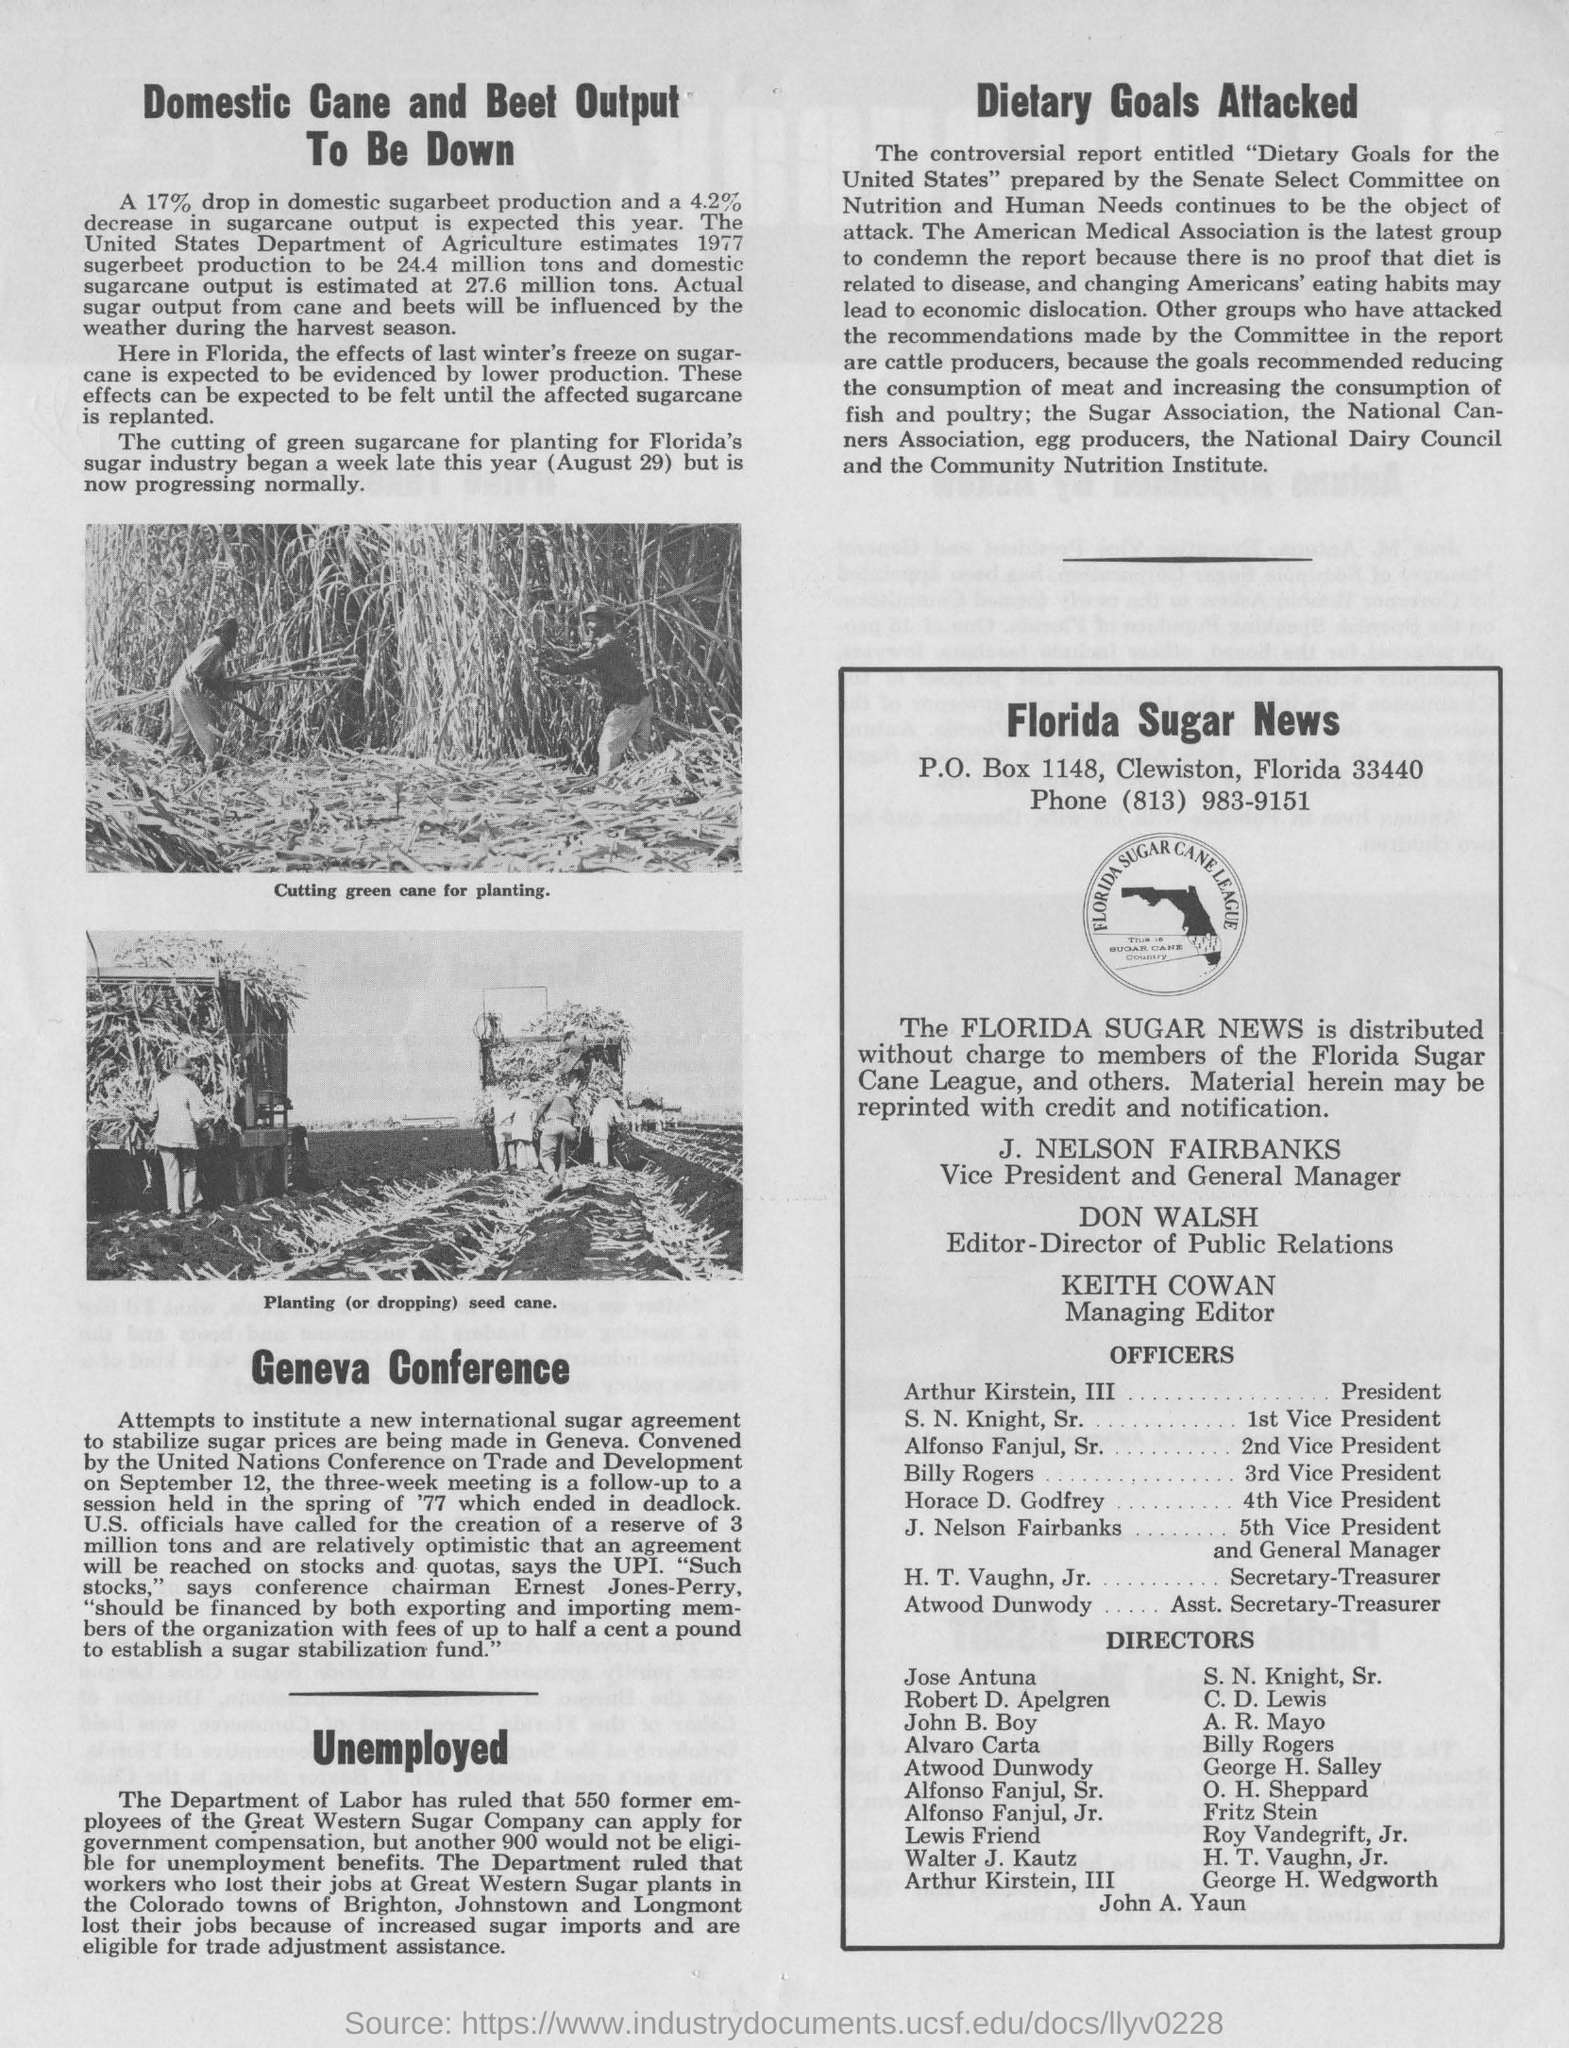Who is the Vice President and General Manager of The Florida Sugar News?
Make the answer very short. J. NELSON FAIRBANKS. What is the designation of Keith Cowan?
Your answer should be very brief. Managing Editor. How much percentage drop in domestic sugarbeet production is expected this year?
Offer a very short reply. 17%. How much percentage decrease in sugarcane output is expected this year?
Make the answer very short. 4.2%. Who prepared the controversial report entitled "Dietary Goals for the United States" ?
Ensure brevity in your answer.  Senate Select Committee on Nutrition and Human Needs. When did the cutting of green sugarcane for planting of Florida's sugar industry began?
Your response must be concise. A week later this year (august 29). 